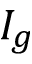<formula> <loc_0><loc_0><loc_500><loc_500>I _ { g }</formula> 